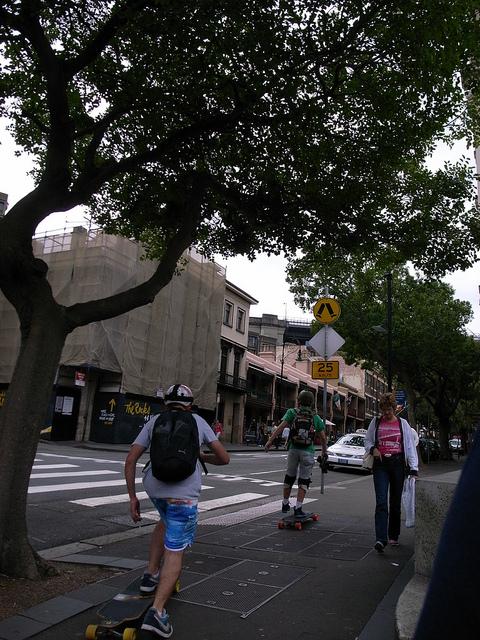What is he gonna step on?
Answer briefly. Sidewalk. What color is the street sign?
Concise answer only. Yellow. How many people are not on skateboards?
Short answer required. 1. How many street signs are there?
Concise answer only. 3. 